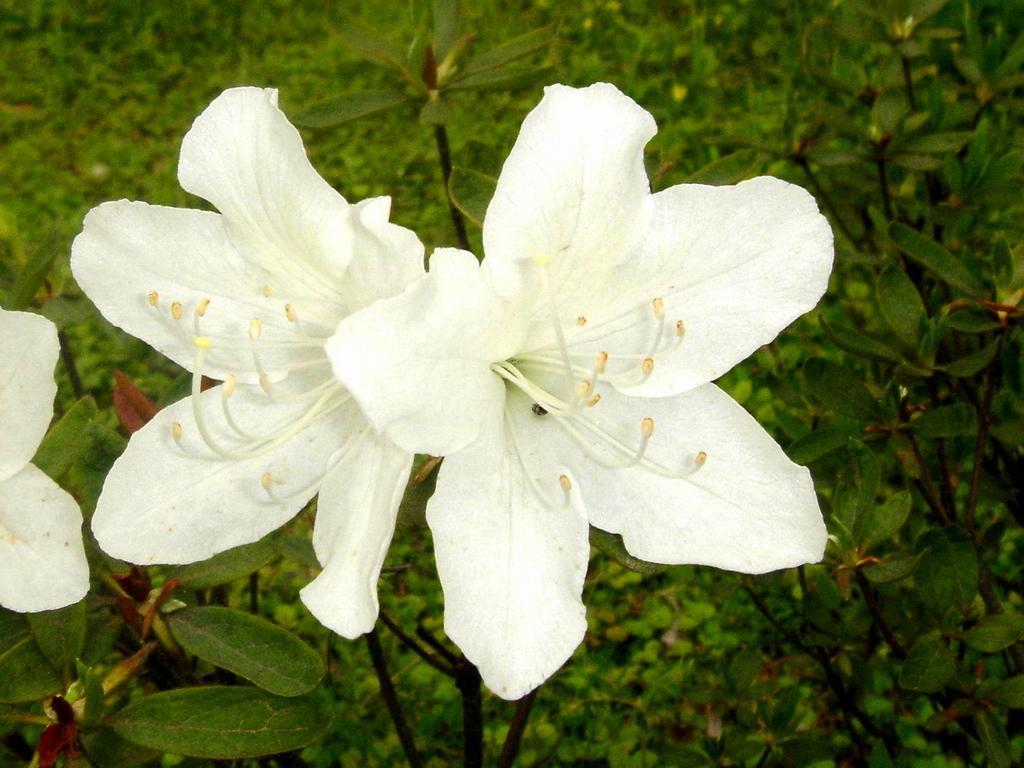Can you describe this image briefly? In this image, we can see flowers with plants. Background there are so many plants we can see. 